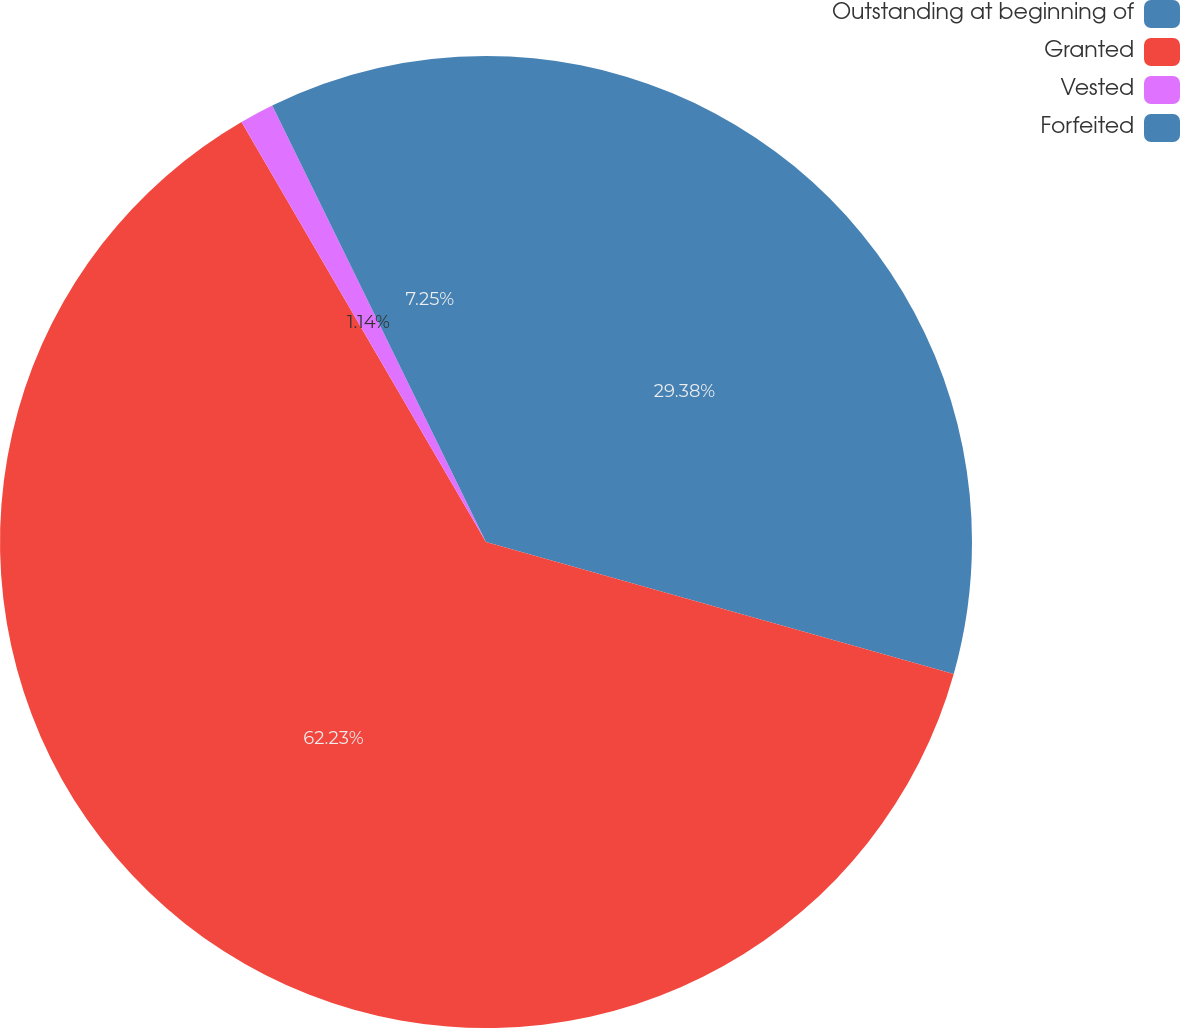<chart> <loc_0><loc_0><loc_500><loc_500><pie_chart><fcel>Outstanding at beginning of<fcel>Granted<fcel>Vested<fcel>Forfeited<nl><fcel>29.38%<fcel>62.24%<fcel>1.14%<fcel>7.25%<nl></chart> 